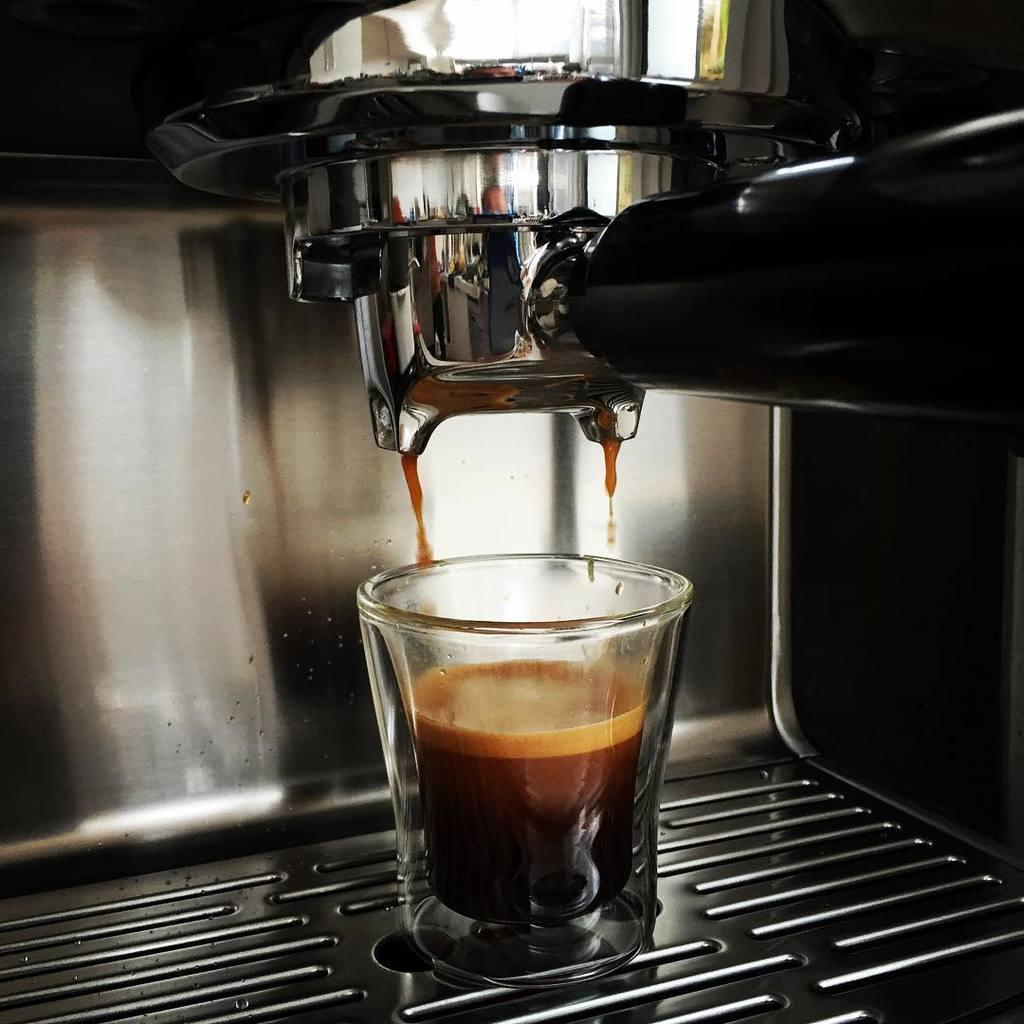What is contained in the glass that is visible in the image? There is a glass of liquid in the image. What appliance can be seen in the image? There is a coffee machine in the image. How does the gate control the flow of liquid in the image? There is no gate present in the image; it only features a glass of liquid and a coffee machine. 